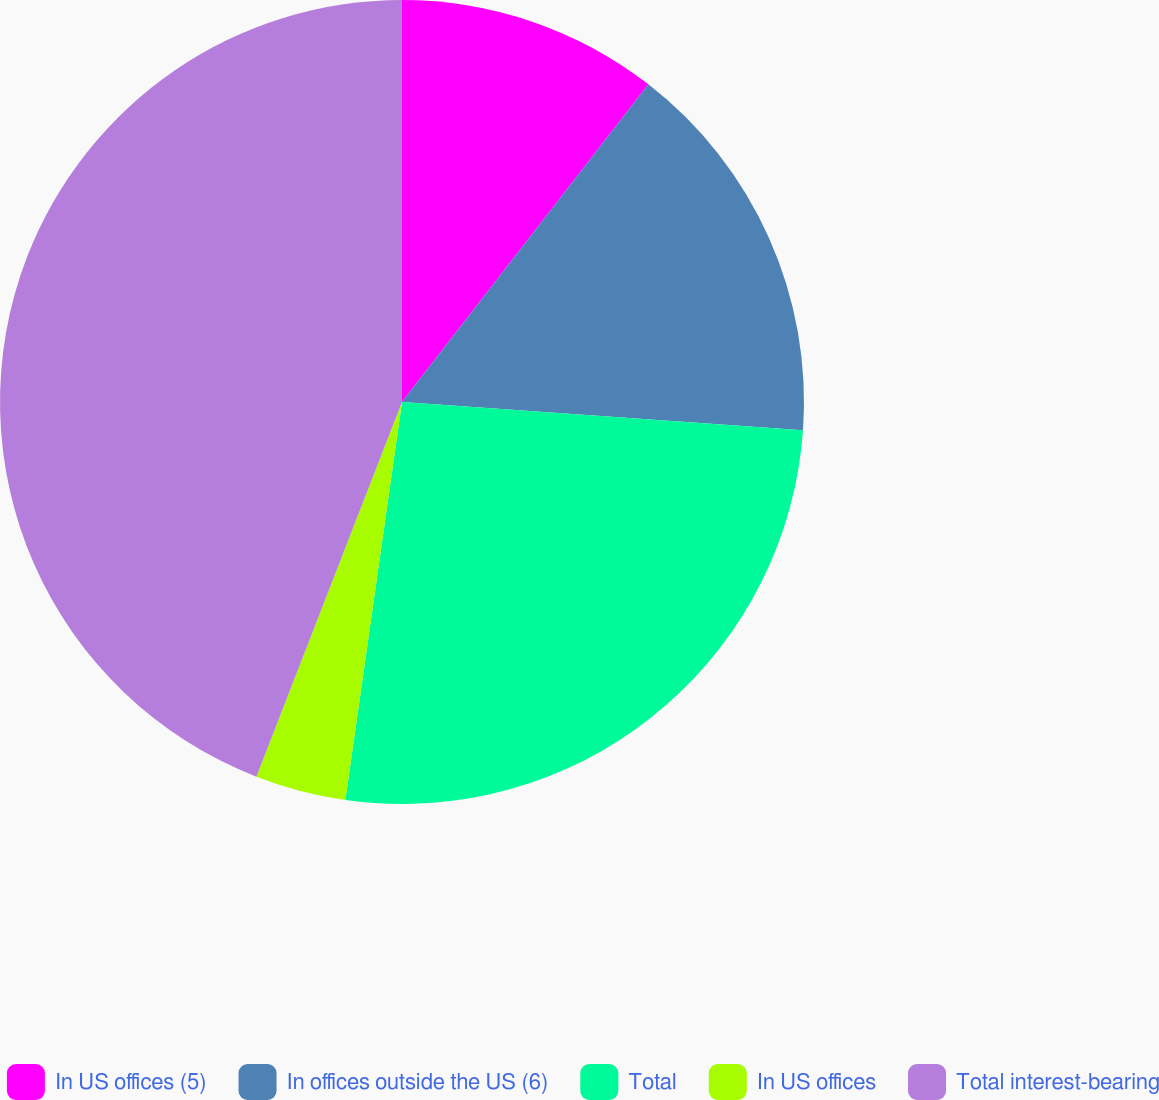Convert chart. <chart><loc_0><loc_0><loc_500><loc_500><pie_chart><fcel>In US offices (5)<fcel>In offices outside the US (6)<fcel>Total<fcel>In US offices<fcel>Total interest-bearing<nl><fcel>10.5%<fcel>15.62%<fcel>26.13%<fcel>3.65%<fcel>44.1%<nl></chart> 